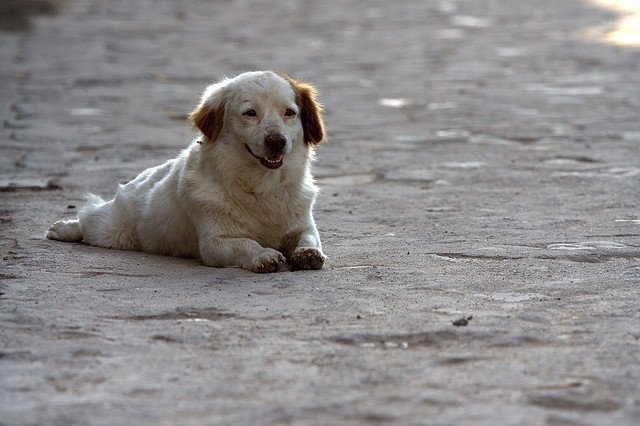Describe the objects in this image and their specific colors. I can see a dog in black, gray, maroon, and darkgray tones in this image. 